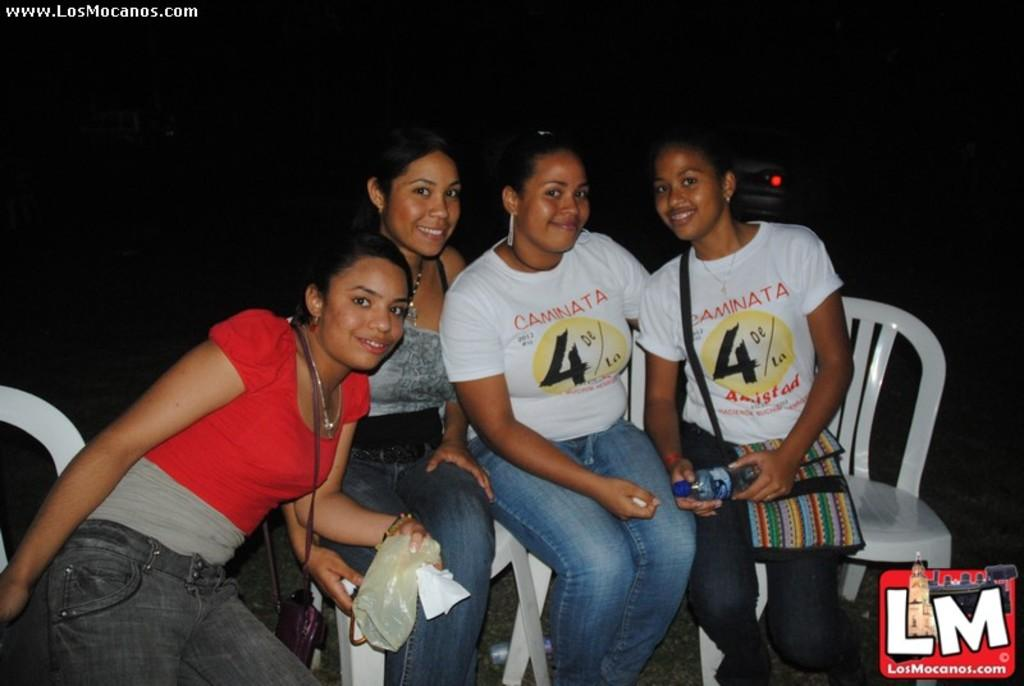What are the people in the image doing? The people in the image are sitting on chairs. What are the people holding in their hands? The people are holding objects. Can you describe any symbols or logos in the image? There is a logo symbol at the bottom of the image. Where is the text located in the image? The text is at the top left corner of the image. How many trucks are visible in the image? There are no trucks present in the image. What grade is the person in the image receiving? There is no indication of a grade or any educational context in the image. 